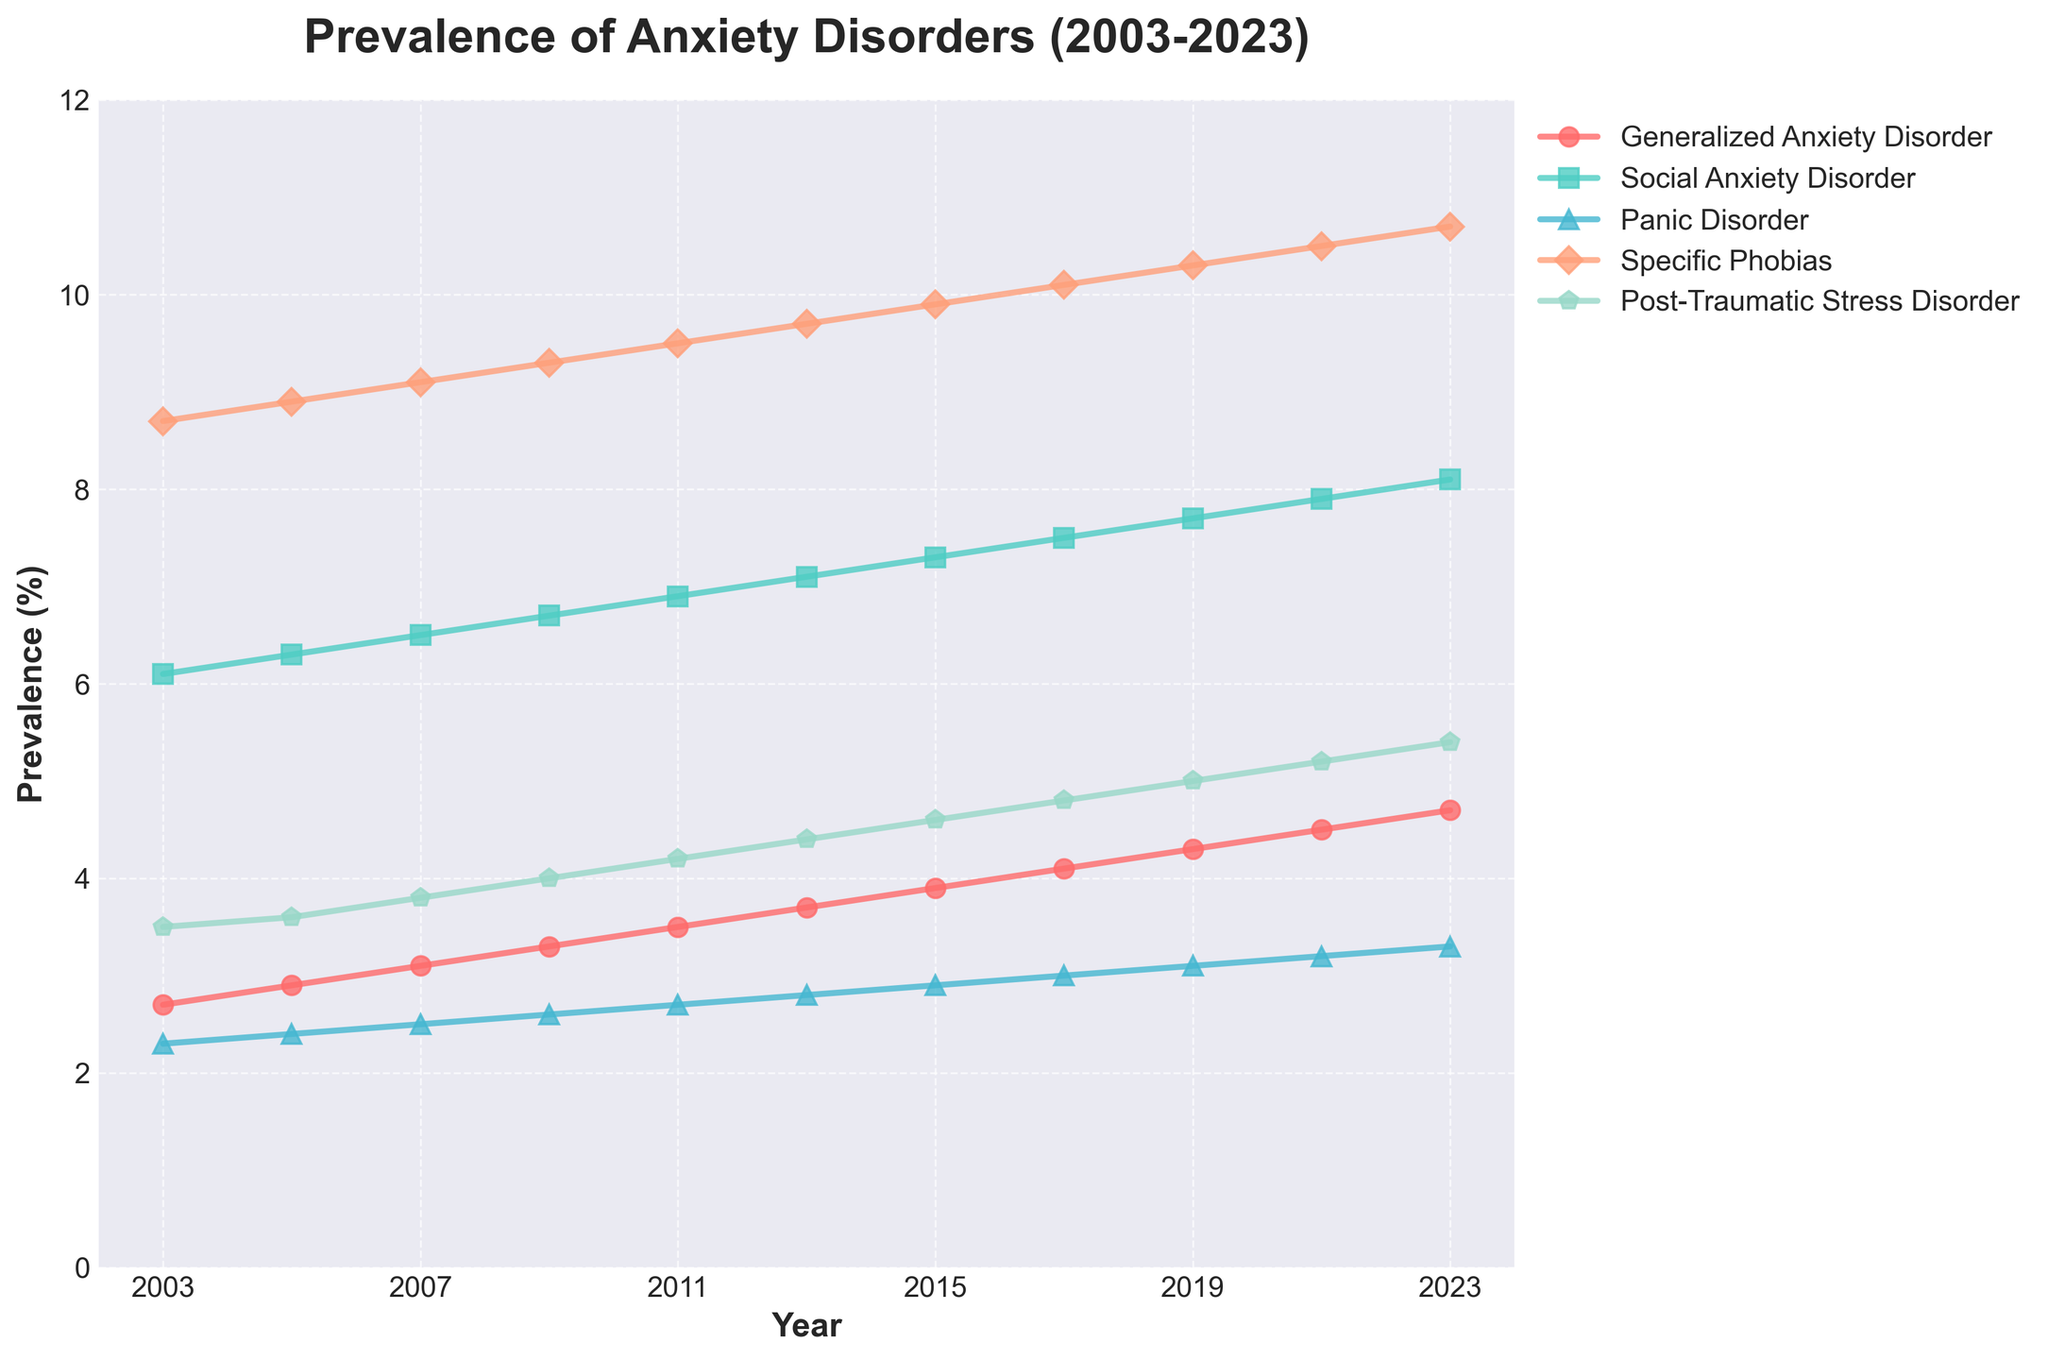Which anxiety disorder saw the highest increase in prevalence from 2003 to 2023? To find the highest increase in prevalence, we subtract the 2003 value from the 2023 value for each disorder. Generalized Anxiety Disorder: 4.7 - 2.7 = 2.0, Social Anxiety Disorder: 8.1 - 6.1 = 2.0, Panic Disorder: 3.3 - 2.3 = 1.0, Specific Phobias: 10.7 - 8.7 = 2.0, Post-Traumatic Stress Disorder: 5.4 - 3.5 = 1.9. Hence, Generalized Anxiety Disorder, Social Anxiety Disorder, and Specific Phobias all had the highest increase of 2.0%.
Answer: Generalized Anxiety Disorder, Social Anxiety Disorder, and Specific Phobias What is the average prevalence of Panic Disorder over the studied years? To calculate this, we sum all the prevalence values for Panic Disorder and divide by the number of data points. Sum = 2.3 + 2.4 + 2.5 + 2.6 + 2.7 + 2.8 + 2.9 + 3.0 + 3.1 + 3.2 + 3.3 = 33.8. Number of years = 11. Average = 33.8 / 11 ≈ 3.07.
Answer: 3.07 In which year did Specific Phobias first exceed a prevalence of 10%? By looking at the data line for Specific Phobias, we can see it first exceeded 10% in 2017.
Answer: 2017 How does the prevalence of Post-Traumatic Stress Disorder in 2023 compare to that in 2003? We compare the values directly. In 2003, the prevalence was 3.5%, and in 2023, it was 5.4%. Thus, it increased by 1.9%.
Answer: Increased by 1.9% Which disorder had the lowest prevalence in 2021? By examining the 2021 data points, we see that Panic Disorder had the lowest prevalence at 3.2%.
Answer: Panic Disorder By how much did Social Anxiety Disorder increase from 2003 to 2013? Subtract the 2003 value from the 2013 value for Social Anxiety Disorder. 7.1 - 6.1 = 1.0%.
Answer: 1.0% Compare the relative prevalence increase of Panic Disorder and Generalized Anxiety Disorder from 2003 to 2023. Which had a higher percentage increase? Calculate the percentage increase for each: Panic Disorder: (3.3 - 2.3) / 2.3 * 100 ≈ 43.5%. Generalized Anxiety Disorder: (4.7 - 2.7) / 2.7 * 100 ≈ 74.1%. Generalized Anxiety Disorder had a higher percentage increase.
Answer: Generalized Anxiety Disorder Which disorder had a steady increase in prevalence over the years? Observing the trends, Generalized Anxiety Disorder shows a consistent and steady increase in prevalence from 2003 to 2023.
Answer: Generalized Anxiety Disorder What are the colors used to represent Panic Disorder and Specific Phobias in the figure? Panic Disorder is represented by a blue color, and Specific Phobias are represented by a pale coral color.
Answer: Blue for Panic Disorder and Pale Coral for Specific Phobias Which year saw the highest overall combined prevalence of all the disorders? Summing up the prevalence values for each year and identifying the year with the highest total. 2023: 4.7 + 8.1 + 3.3 + 10.7 + 5.4 = 32.2%. Hence, the year with the highest overall combined prevalence of all disorders is 2023.
Answer: 2023 